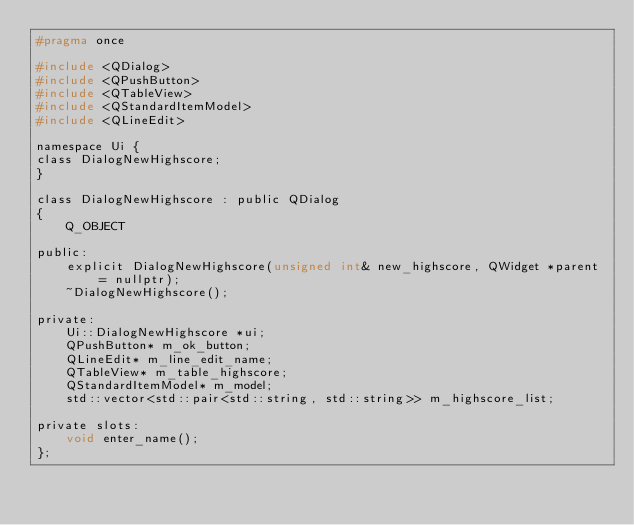<code> <loc_0><loc_0><loc_500><loc_500><_C_>#pragma once

#include <QDialog>
#include <QPushButton>
#include <QTableView>
#include <QStandardItemModel>
#include <QLineEdit>

namespace Ui {
class DialogNewHighscore;
}

class DialogNewHighscore : public QDialog
{
    Q_OBJECT

public:
    explicit DialogNewHighscore(unsigned int& new_highscore, QWidget *parent = nullptr);
    ~DialogNewHighscore();

private:
    Ui::DialogNewHighscore *ui;
    QPushButton* m_ok_button;
    QLineEdit* m_line_edit_name;
    QTableView* m_table_highscore;
    QStandardItemModel* m_model;
    std::vector<std::pair<std::string, std::string>> m_highscore_list;

private slots:
    void enter_name();
};
</code> 